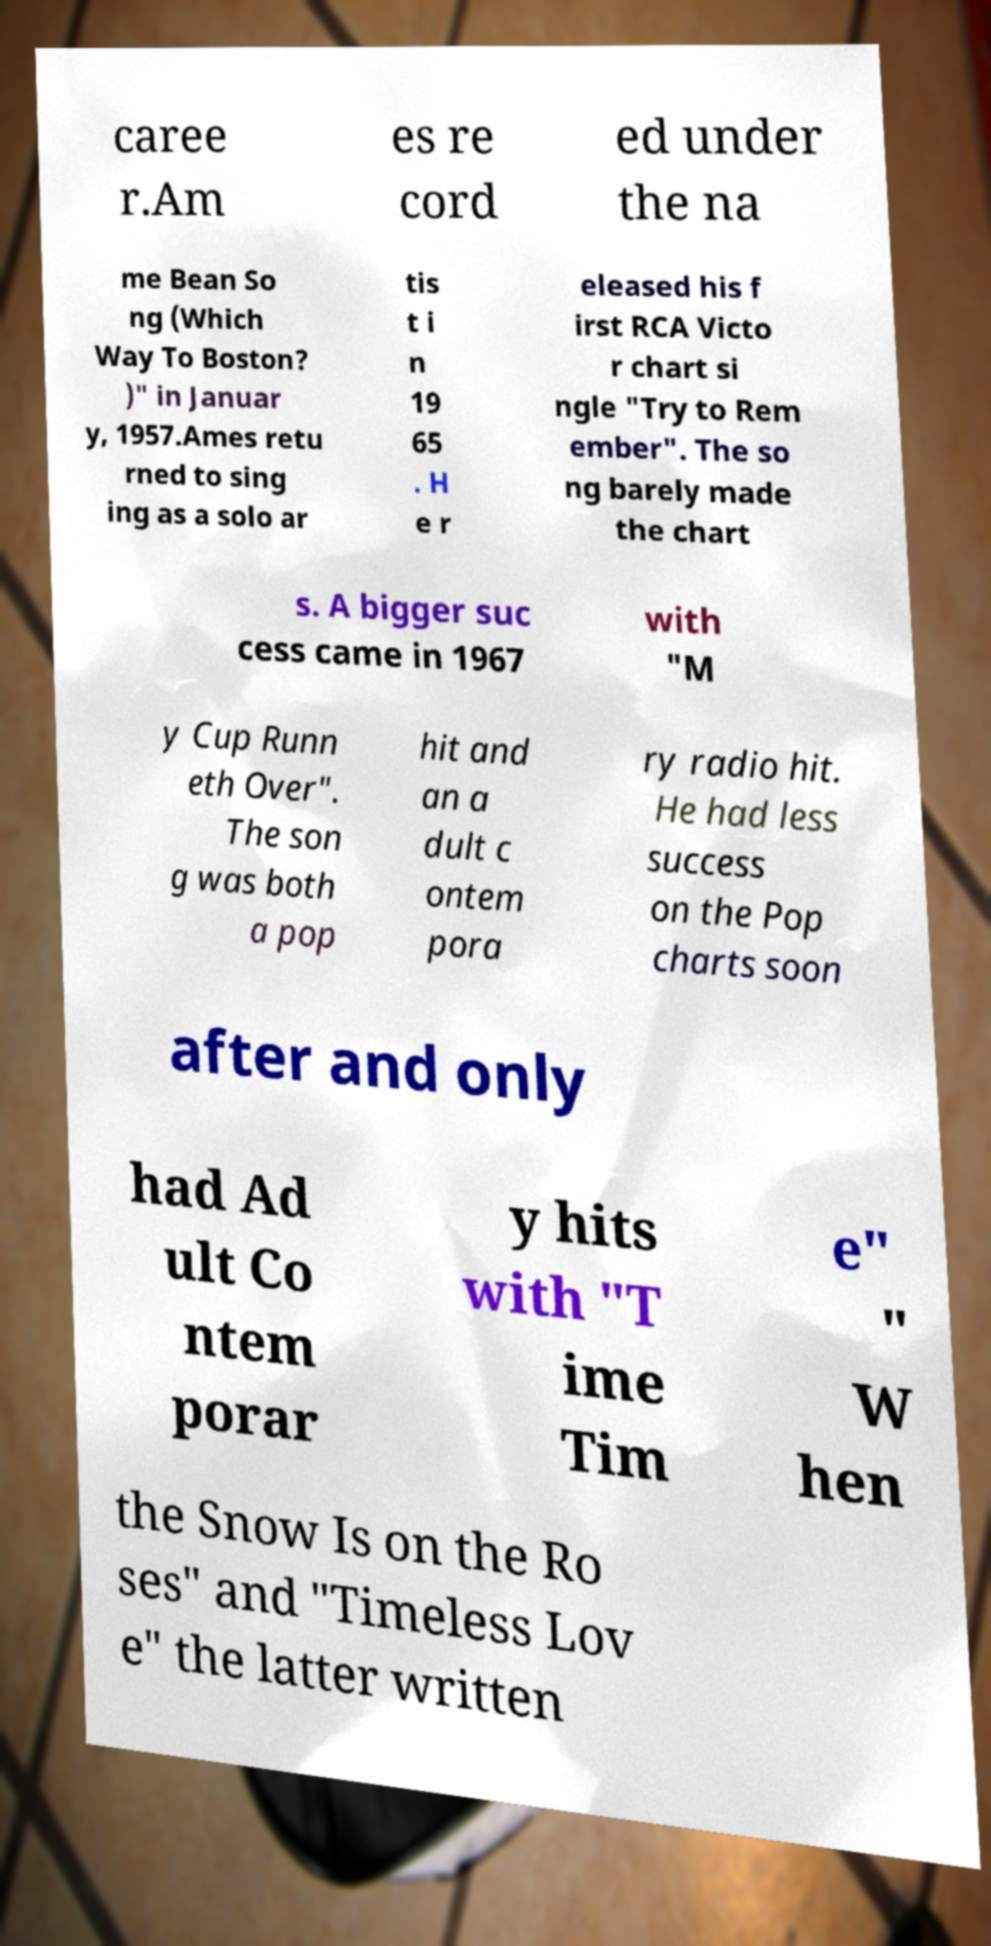Could you extract and type out the text from this image? caree r.Am es re cord ed under the na me Bean So ng (Which Way To Boston? )" in Januar y, 1957.Ames retu rned to sing ing as a solo ar tis t i n 19 65 . H e r eleased his f irst RCA Victo r chart si ngle "Try to Rem ember". The so ng barely made the chart s. A bigger suc cess came in 1967 with "M y Cup Runn eth Over". The son g was both a pop hit and an a dult c ontem pora ry radio hit. He had less success on the Pop charts soon after and only had Ad ult Co ntem porar y hits with "T ime Tim e" " W hen the Snow Is on the Ro ses" and "Timeless Lov e" the latter written 